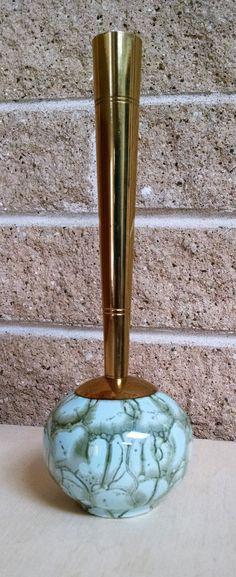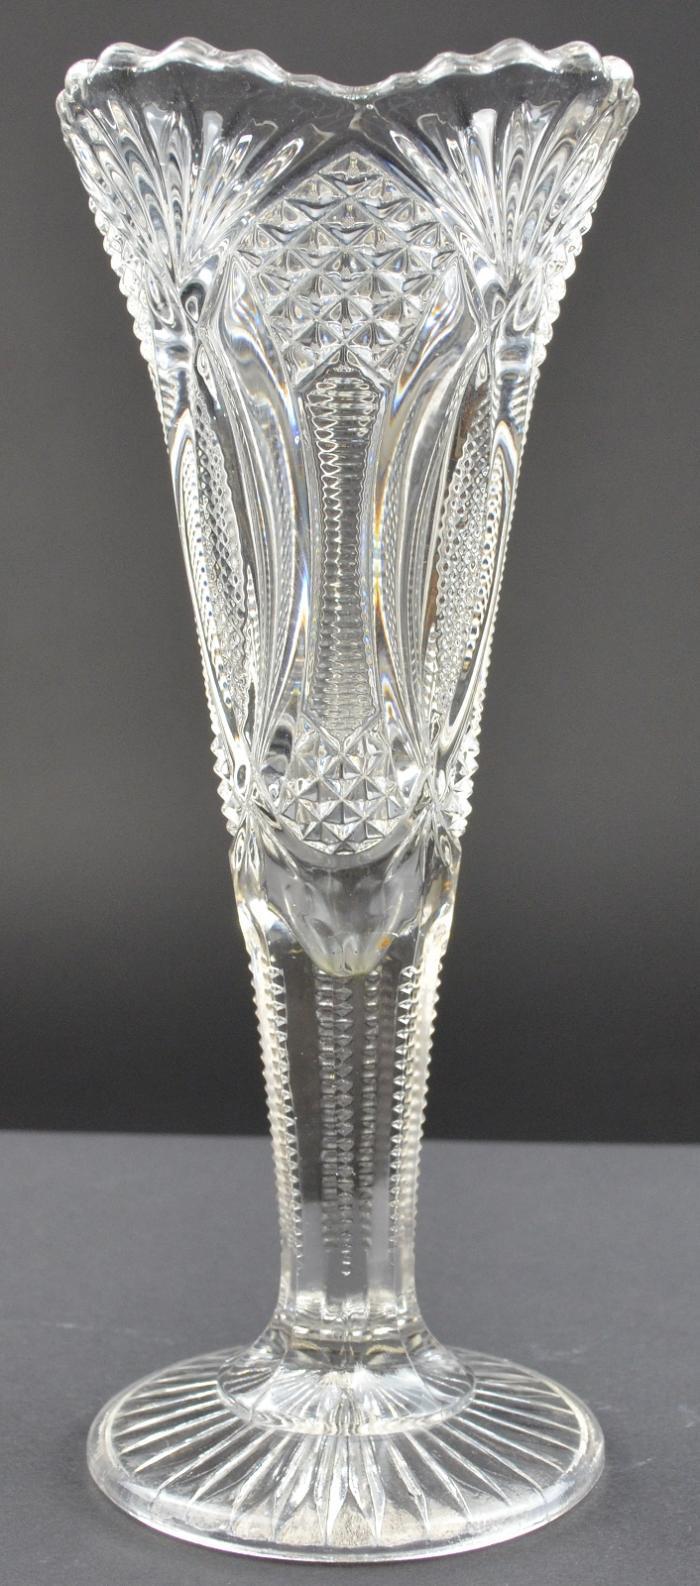The first image is the image on the left, the second image is the image on the right. Evaluate the accuracy of this statement regarding the images: "An image shows a vase with a curl like an ocean wave at the bottom.". Is it true? Answer yes or no. No. 